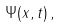<formula> <loc_0><loc_0><loc_500><loc_500>\Psi ( x , t ) \, ,</formula> 